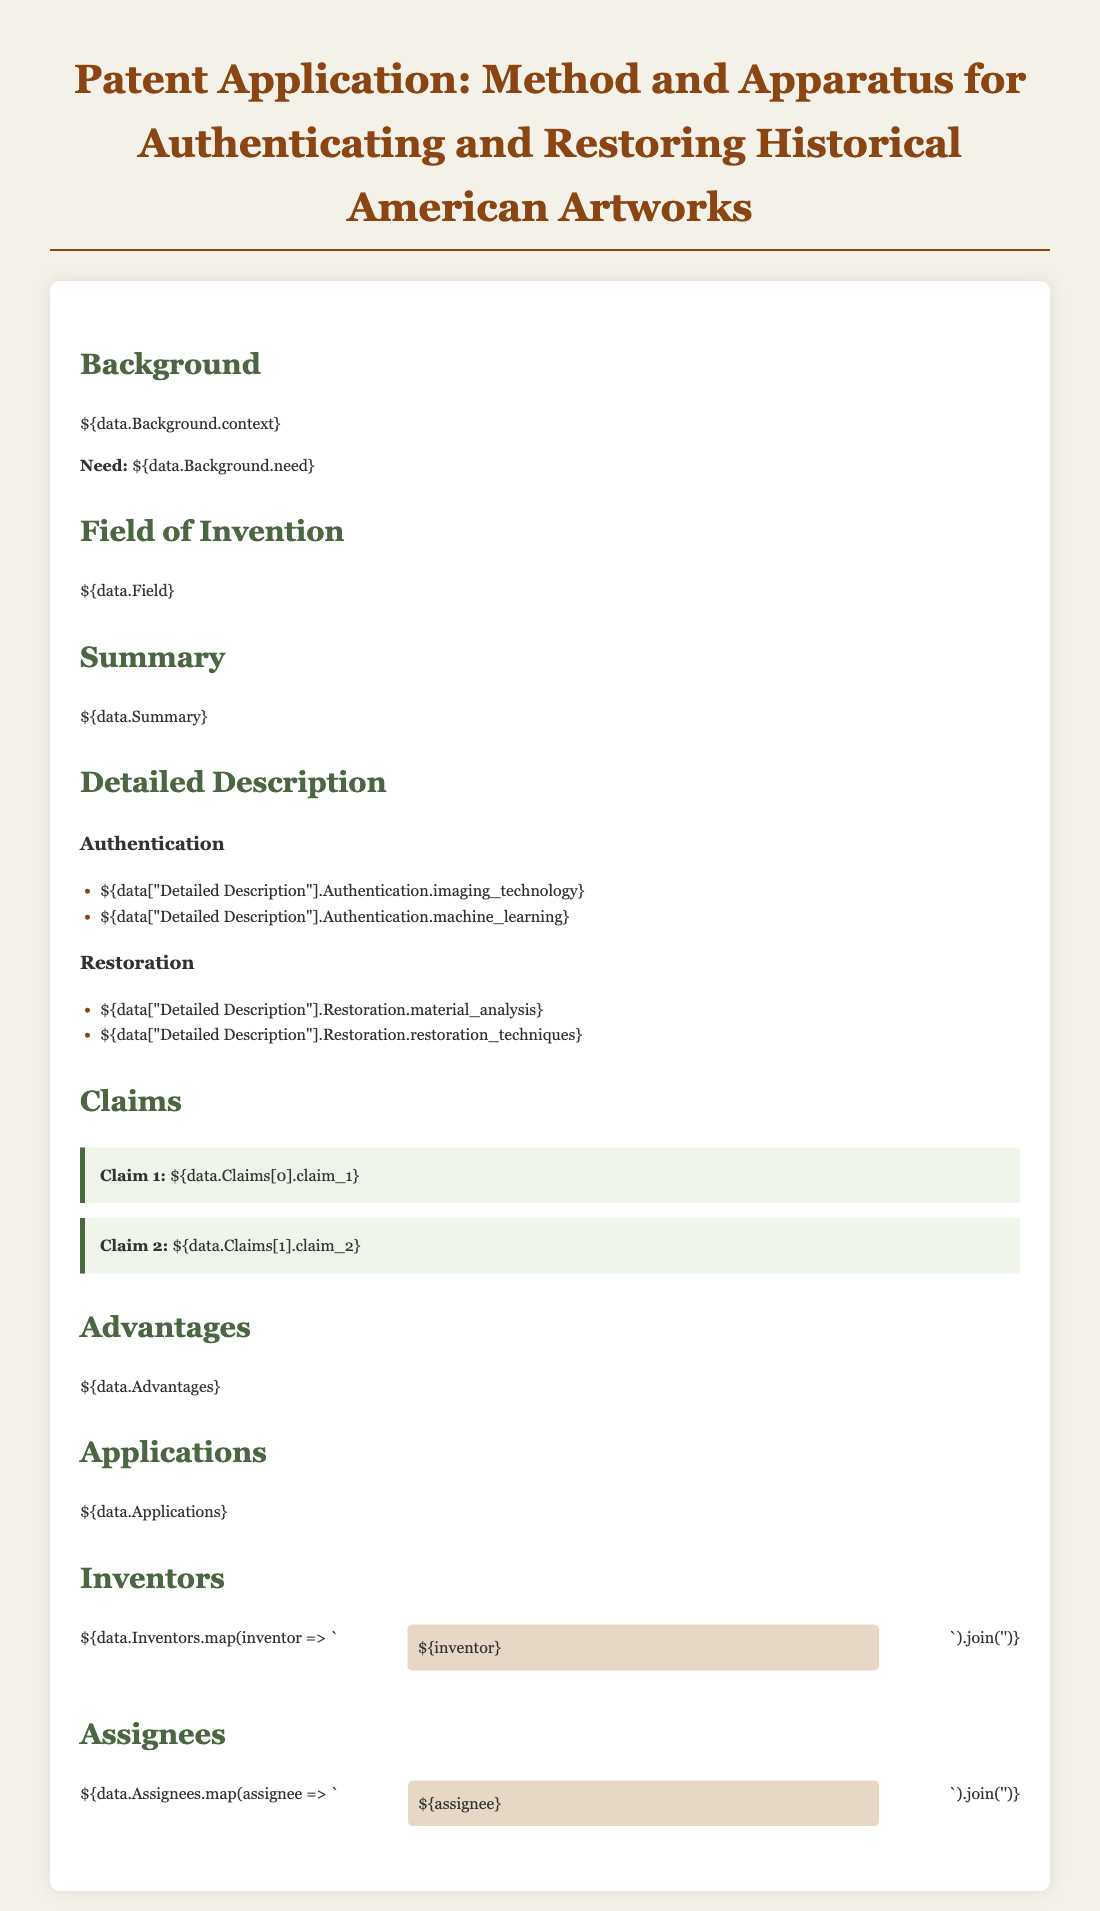What is the title of the patent application? The title is provided prominently at the top of the document.
Answer: Method and Apparatus for Authenticating and Restoring Historical American Artworks Who are the inventors listed? The document includes a section detailing the inventors involved in the patent.
Answer: [Inventors' names as listed in the document] What is the need identified in the Background section? The need is explicitly stated in the Background section of the document.
Answer: [Need as described in the document] Which technologies are used for authentication? The detailed description section lists specific technologies related to authentication.
Answer: Imaging technology and machine learning What claim is made regarding restoration techniques? Claims are stated in their individual sections, detailing what is asserted about restoration.
Answer: [Claim for restoration techniques as per the document] What is the primary field of invention? This information is located in the respective section dedicated to the field of invention.
Answer: [Field as mentioned in the document] What is one advantage of the proposed method? Advantages are specifically outlined in a relevant section of the document.
Answer: [One advantage described in the document] How many claims are presented? The number of claims can be counted from the claims section in the document.
Answer: 2 In which section is the summary of the invention found? The summary is distinctly labeled and can be easily identified within the document.
Answer: Summary section What applications are stated for this patent? The applications of the patent are mentioned in a dedicated section.
Answer: [Applications as outlined in the document] 